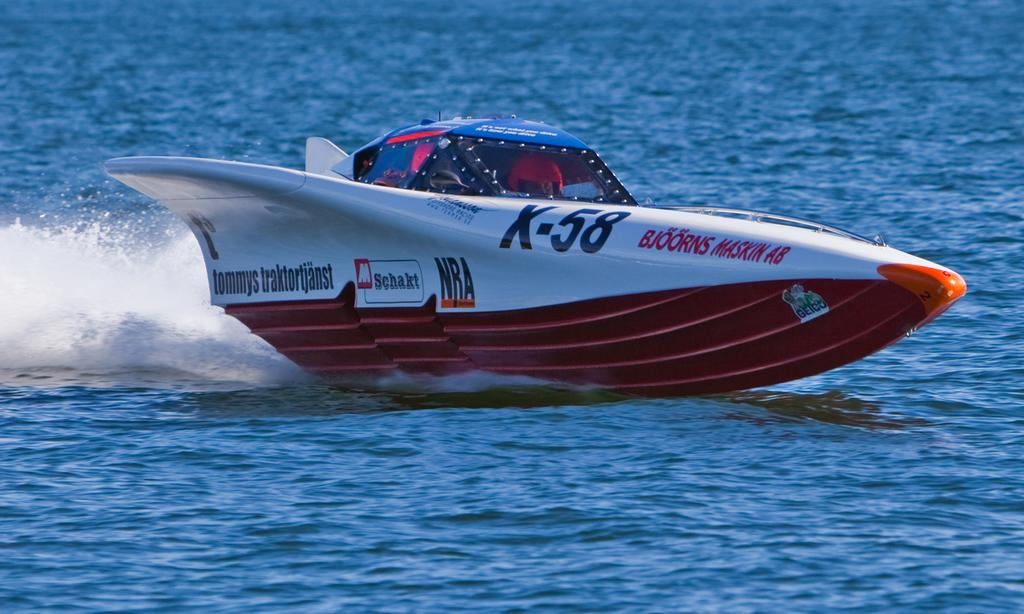What is the main subject of the image? The main subject of the image is a boat. Where is the boat located? The boat is on the water. What type of health benefits can be gained from the boat in the image? There are no health benefits associated with the boat in the image, as it is an inanimate object. 